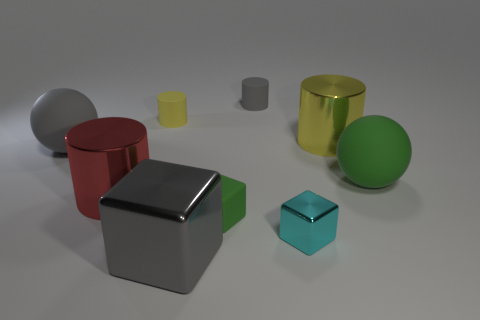Are there any other things that have the same color as the large metal block?
Provide a short and direct response. Yes. There is a matte sphere that is on the right side of the yellow cylinder on the left side of the gray rubber cylinder; is there a tiny yellow object in front of it?
Provide a succinct answer. No. There is a large matte object that is right of the big yellow shiny thing; is it the same shape as the red thing?
Offer a terse response. No. Is the number of cyan objects behind the gray sphere less than the number of large shiny objects that are to the right of the small yellow thing?
Your answer should be compact. Yes. What is the small gray cylinder made of?
Your answer should be compact. Rubber. Is the color of the small metal cube the same as the big sphere that is in front of the gray ball?
Provide a succinct answer. No. There is a cyan thing; what number of big shiny things are to the left of it?
Offer a very short reply. 2. Is the number of red objects in front of the red cylinder less than the number of large green rubber spheres?
Provide a succinct answer. Yes. The large metallic block is what color?
Your answer should be very brief. Gray. There is a large matte sphere right of the cyan metallic object; is it the same color as the small matte block?
Provide a succinct answer. Yes. 